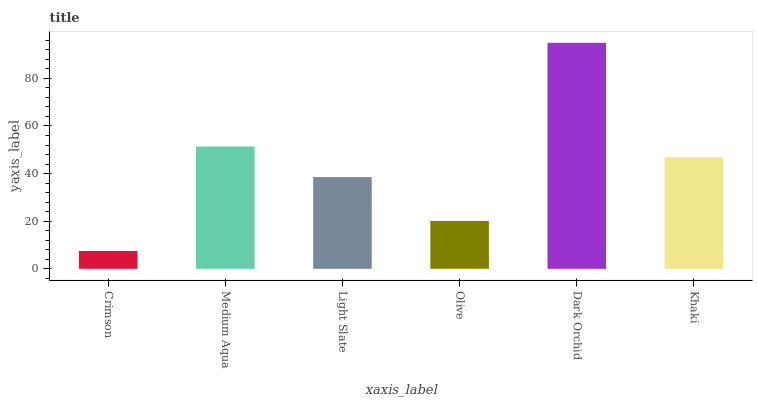Is Crimson the minimum?
Answer yes or no. Yes. Is Dark Orchid the maximum?
Answer yes or no. Yes. Is Medium Aqua the minimum?
Answer yes or no. No. Is Medium Aqua the maximum?
Answer yes or no. No. Is Medium Aqua greater than Crimson?
Answer yes or no. Yes. Is Crimson less than Medium Aqua?
Answer yes or no. Yes. Is Crimson greater than Medium Aqua?
Answer yes or no. No. Is Medium Aqua less than Crimson?
Answer yes or no. No. Is Khaki the high median?
Answer yes or no. Yes. Is Light Slate the low median?
Answer yes or no. Yes. Is Olive the high median?
Answer yes or no. No. Is Dark Orchid the low median?
Answer yes or no. No. 